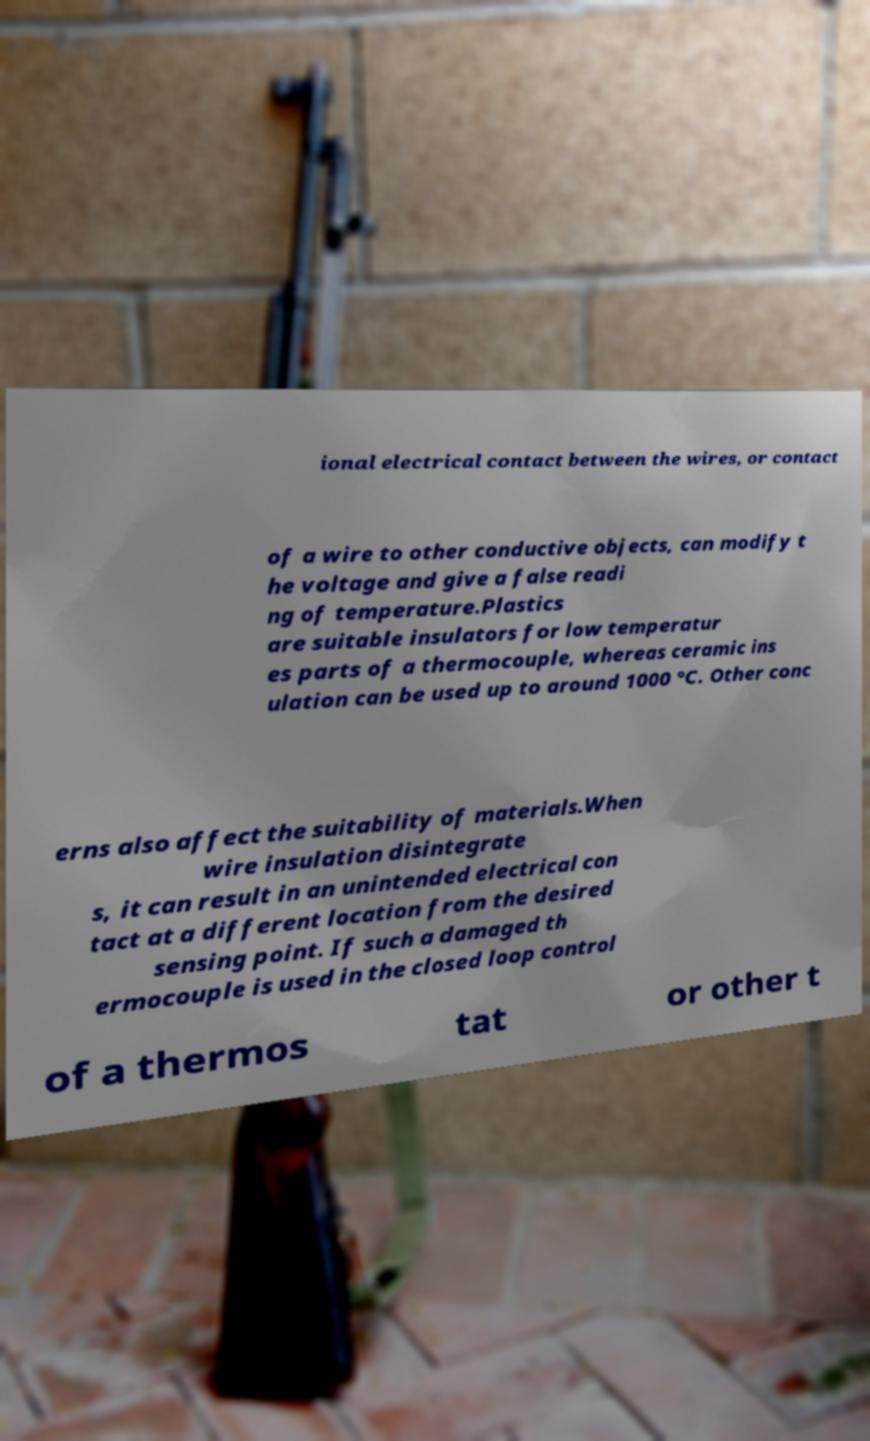I need the written content from this picture converted into text. Can you do that? ional electrical contact between the wires, or contact of a wire to other conductive objects, can modify t he voltage and give a false readi ng of temperature.Plastics are suitable insulators for low temperatur es parts of a thermocouple, whereas ceramic ins ulation can be used up to around 1000 °C. Other conc erns also affect the suitability of materials.When wire insulation disintegrate s, it can result in an unintended electrical con tact at a different location from the desired sensing point. If such a damaged th ermocouple is used in the closed loop control of a thermos tat or other t 